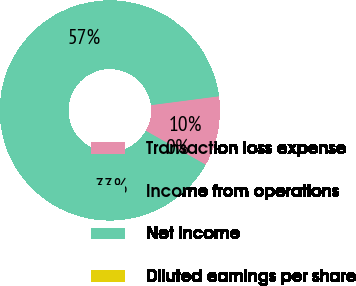Convert chart. <chart><loc_0><loc_0><loc_500><loc_500><pie_chart><fcel>Transaction loss expense<fcel>Income from operations<fcel>Net income<fcel>Diluted earnings per share<nl><fcel>10.27%<fcel>56.64%<fcel>33.08%<fcel>0.0%<nl></chart> 